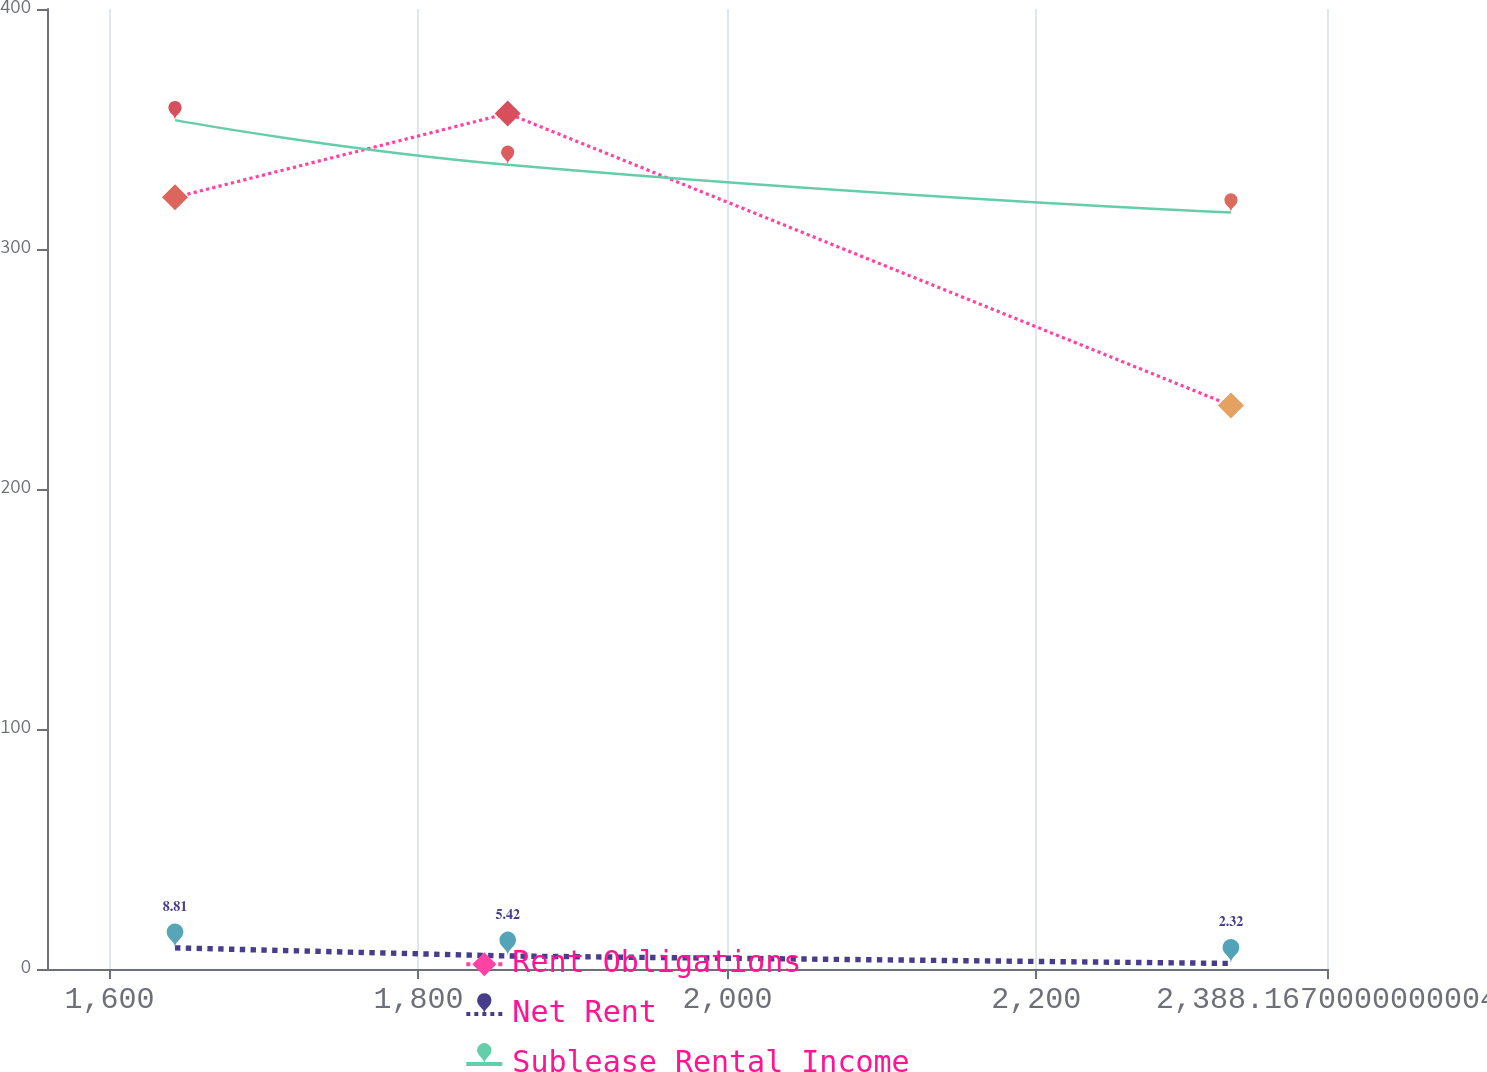Convert chart. <chart><loc_0><loc_0><loc_500><loc_500><line_chart><ecel><fcel>Rent Obligations<fcel>Net Rent<fcel>Sublease Rental Income<nl><fcel>1642.4<fcel>321.53<fcel>8.81<fcel>353.7<nl><fcel>1857.79<fcel>356.47<fcel>5.42<fcel>335.1<nl><fcel>2325.99<fcel>234.82<fcel>2.32<fcel>315.2<nl><fcel>2398.51<fcel>216.02<fcel>1.35<fcel>241.19<nl><fcel>2471.03<fcel>171.63<fcel>0.52<fcel>151.7<nl></chart> 